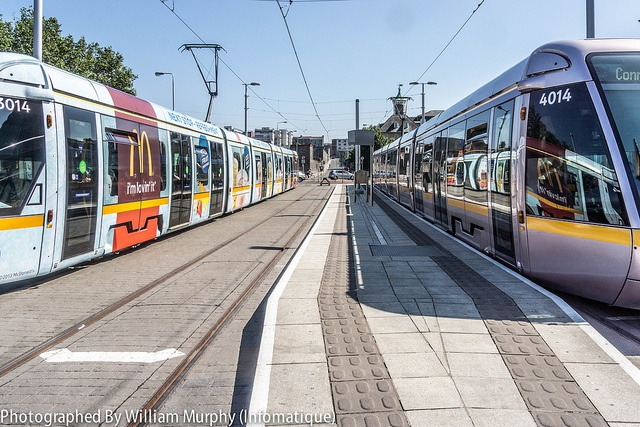Describe the objects in this image and their specific colors. I can see train in lightblue, black, gray, and darkgray tones, train in lightblue, white, gray, black, and darkgray tones, car in lightblue, gray, black, and darkgray tones, and car in lightblue, gray, white, darkgray, and black tones in this image. 